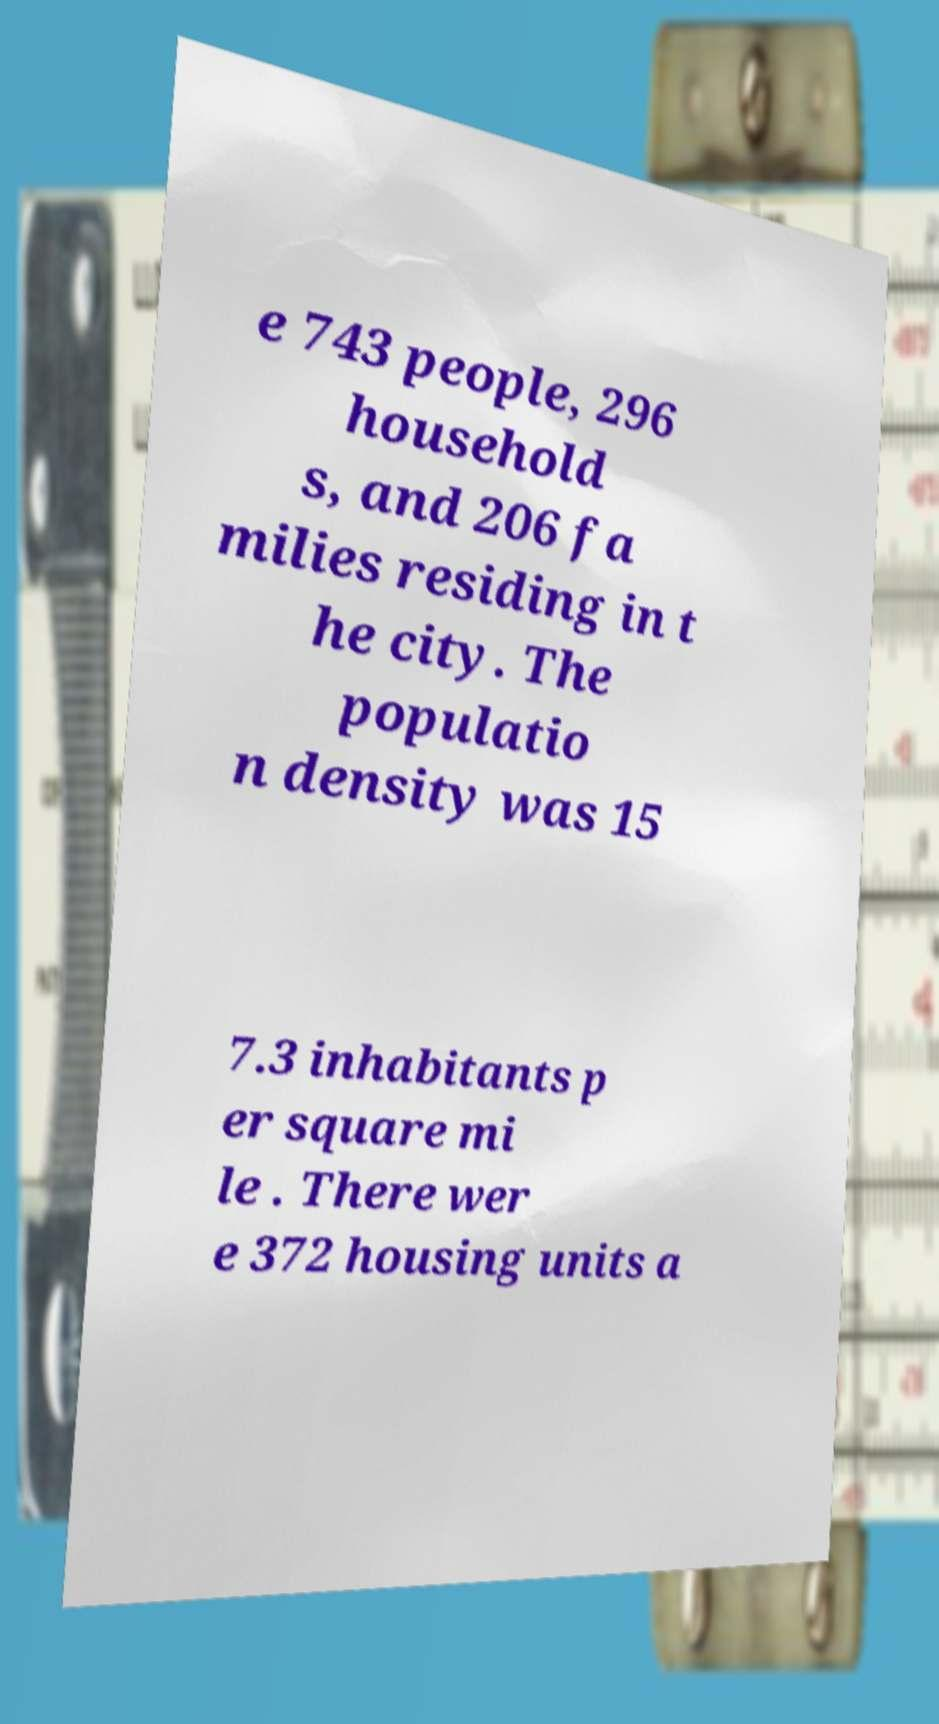Can you read and provide the text displayed in the image?This photo seems to have some interesting text. Can you extract and type it out for me? e 743 people, 296 household s, and 206 fa milies residing in t he city. The populatio n density was 15 7.3 inhabitants p er square mi le . There wer e 372 housing units a 